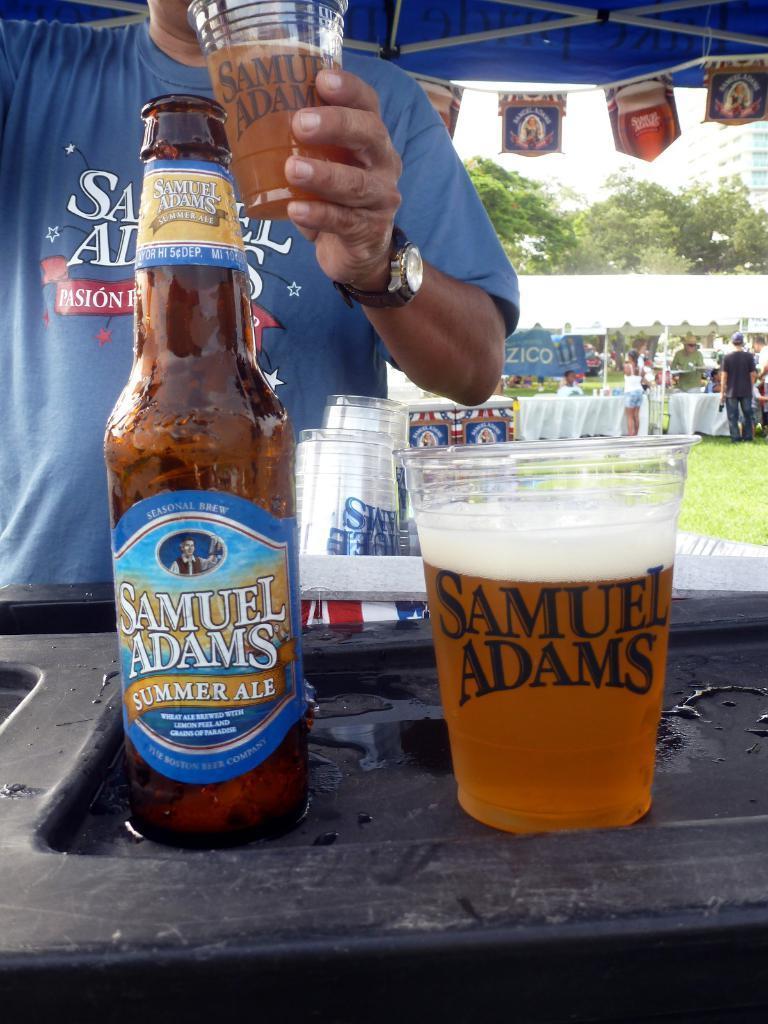Could you give a brief overview of what you see in this image? In this image I can see person holding glass. In front I can see a wine bottle,glasses on the black color tray. Back I can see few people and tents. Back I can see trees and buildings. 